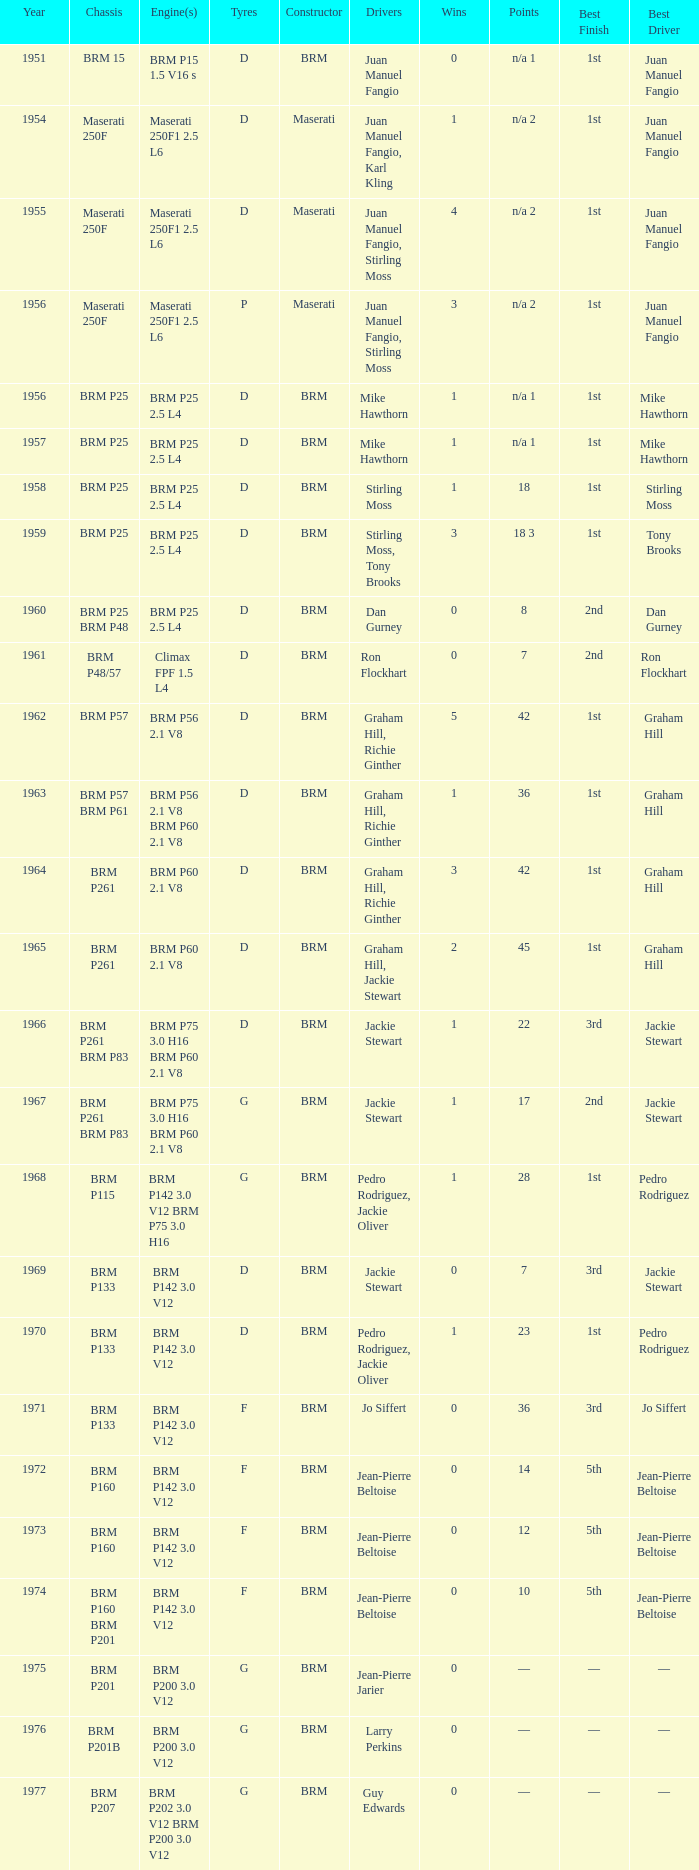Name the chassis of 1961 BRM P48/57. 